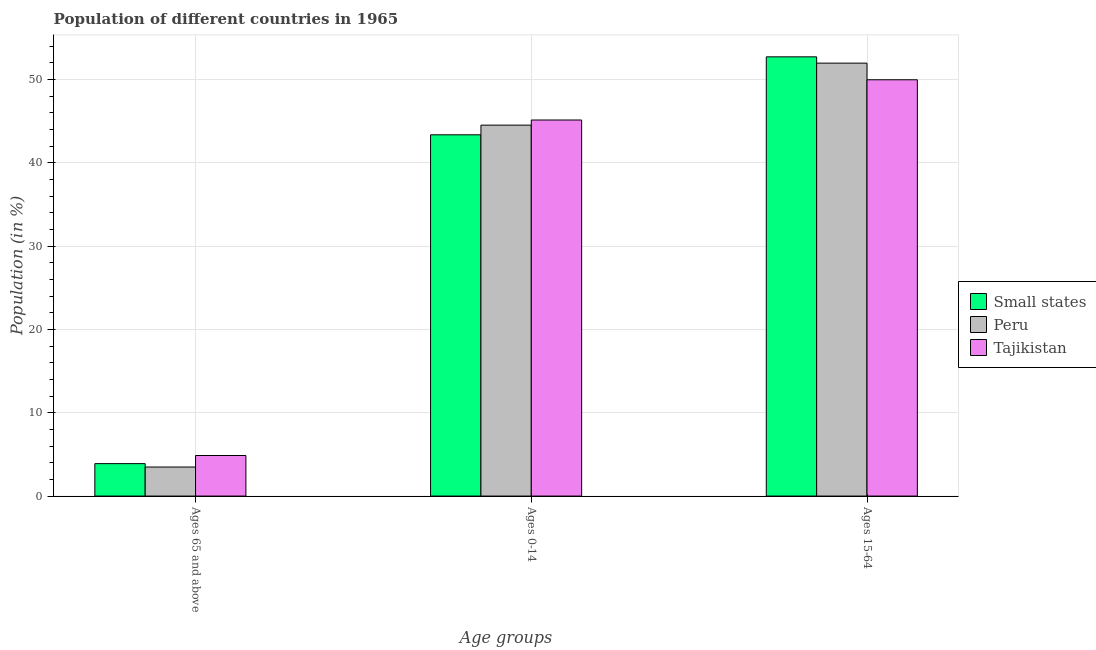How many different coloured bars are there?
Keep it short and to the point. 3. How many groups of bars are there?
Keep it short and to the point. 3. Are the number of bars on each tick of the X-axis equal?
Make the answer very short. Yes. How many bars are there on the 3rd tick from the right?
Offer a terse response. 3. What is the label of the 1st group of bars from the left?
Your answer should be compact. Ages 65 and above. What is the percentage of population within the age-group 0-14 in Peru?
Give a very brief answer. 44.53. Across all countries, what is the maximum percentage of population within the age-group of 65 and above?
Offer a very short reply. 4.87. Across all countries, what is the minimum percentage of population within the age-group 15-64?
Make the answer very short. 49.98. In which country was the percentage of population within the age-group 15-64 maximum?
Your answer should be very brief. Small states. In which country was the percentage of population within the age-group 0-14 minimum?
Your answer should be compact. Small states. What is the total percentage of population within the age-group of 65 and above in the graph?
Offer a very short reply. 12.25. What is the difference between the percentage of population within the age-group 0-14 in Small states and that in Tajikistan?
Keep it short and to the point. -1.78. What is the difference between the percentage of population within the age-group 15-64 in Small states and the percentage of population within the age-group 0-14 in Peru?
Your response must be concise. 8.2. What is the average percentage of population within the age-group of 65 and above per country?
Your answer should be compact. 4.08. What is the difference between the percentage of population within the age-group 15-64 and percentage of population within the age-group 0-14 in Peru?
Your answer should be compact. 7.44. In how many countries, is the percentage of population within the age-group 0-14 greater than 38 %?
Offer a very short reply. 3. What is the ratio of the percentage of population within the age-group of 65 and above in Peru to that in Tajikistan?
Offer a very short reply. 0.72. Is the percentage of population within the age-group of 65 and above in Tajikistan less than that in Small states?
Give a very brief answer. No. Is the difference between the percentage of population within the age-group of 65 and above in Peru and Tajikistan greater than the difference between the percentage of population within the age-group 0-14 in Peru and Tajikistan?
Your answer should be compact. No. What is the difference between the highest and the second highest percentage of population within the age-group 15-64?
Your answer should be compact. 0.76. What is the difference between the highest and the lowest percentage of population within the age-group of 65 and above?
Offer a very short reply. 1.38. What does the 2nd bar from the left in Ages 65 and above represents?
Offer a terse response. Peru. How many bars are there?
Your answer should be compact. 9. What is the difference between two consecutive major ticks on the Y-axis?
Offer a very short reply. 10. Does the graph contain any zero values?
Make the answer very short. No. Where does the legend appear in the graph?
Your answer should be very brief. Center right. How are the legend labels stacked?
Provide a succinct answer. Vertical. What is the title of the graph?
Ensure brevity in your answer.  Population of different countries in 1965. What is the label or title of the X-axis?
Make the answer very short. Age groups. What is the Population (in %) of Small states in Ages 65 and above?
Your answer should be compact. 3.89. What is the Population (in %) of Peru in Ages 65 and above?
Your answer should be compact. 3.49. What is the Population (in %) in Tajikistan in Ages 65 and above?
Ensure brevity in your answer.  4.87. What is the Population (in %) of Small states in Ages 0-14?
Your answer should be compact. 43.37. What is the Population (in %) in Peru in Ages 0-14?
Your response must be concise. 44.53. What is the Population (in %) of Tajikistan in Ages 0-14?
Your answer should be compact. 45.15. What is the Population (in %) of Small states in Ages 15-64?
Your answer should be very brief. 52.73. What is the Population (in %) in Peru in Ages 15-64?
Offer a very short reply. 51.98. What is the Population (in %) in Tajikistan in Ages 15-64?
Your answer should be very brief. 49.98. Across all Age groups, what is the maximum Population (in %) in Small states?
Your answer should be very brief. 52.73. Across all Age groups, what is the maximum Population (in %) in Peru?
Offer a terse response. 51.98. Across all Age groups, what is the maximum Population (in %) in Tajikistan?
Provide a short and direct response. 49.98. Across all Age groups, what is the minimum Population (in %) of Small states?
Your response must be concise. 3.89. Across all Age groups, what is the minimum Population (in %) of Peru?
Offer a terse response. 3.49. Across all Age groups, what is the minimum Population (in %) in Tajikistan?
Make the answer very short. 4.87. What is the total Population (in %) in Small states in the graph?
Offer a terse response. 100. What is the total Population (in %) in Tajikistan in the graph?
Ensure brevity in your answer.  100. What is the difference between the Population (in %) of Small states in Ages 65 and above and that in Ages 0-14?
Your answer should be very brief. -39.48. What is the difference between the Population (in %) of Peru in Ages 65 and above and that in Ages 0-14?
Give a very brief answer. -41.05. What is the difference between the Population (in %) in Tajikistan in Ages 65 and above and that in Ages 0-14?
Provide a short and direct response. -40.28. What is the difference between the Population (in %) in Small states in Ages 65 and above and that in Ages 15-64?
Your answer should be compact. -48.84. What is the difference between the Population (in %) of Peru in Ages 65 and above and that in Ages 15-64?
Provide a short and direct response. -48.49. What is the difference between the Population (in %) of Tajikistan in Ages 65 and above and that in Ages 15-64?
Your answer should be very brief. -45.11. What is the difference between the Population (in %) of Small states in Ages 0-14 and that in Ages 15-64?
Offer a very short reply. -9.36. What is the difference between the Population (in %) in Peru in Ages 0-14 and that in Ages 15-64?
Your response must be concise. -7.44. What is the difference between the Population (in %) in Tajikistan in Ages 0-14 and that in Ages 15-64?
Ensure brevity in your answer.  -4.83. What is the difference between the Population (in %) in Small states in Ages 65 and above and the Population (in %) in Peru in Ages 0-14?
Give a very brief answer. -40.64. What is the difference between the Population (in %) in Small states in Ages 65 and above and the Population (in %) in Tajikistan in Ages 0-14?
Keep it short and to the point. -41.26. What is the difference between the Population (in %) in Peru in Ages 65 and above and the Population (in %) in Tajikistan in Ages 0-14?
Keep it short and to the point. -41.66. What is the difference between the Population (in %) in Small states in Ages 65 and above and the Population (in %) in Peru in Ages 15-64?
Your answer should be very brief. -48.09. What is the difference between the Population (in %) in Small states in Ages 65 and above and the Population (in %) in Tajikistan in Ages 15-64?
Provide a succinct answer. -46.09. What is the difference between the Population (in %) in Peru in Ages 65 and above and the Population (in %) in Tajikistan in Ages 15-64?
Your response must be concise. -46.49. What is the difference between the Population (in %) of Small states in Ages 0-14 and the Population (in %) of Peru in Ages 15-64?
Keep it short and to the point. -8.61. What is the difference between the Population (in %) in Small states in Ages 0-14 and the Population (in %) in Tajikistan in Ages 15-64?
Your response must be concise. -6.61. What is the difference between the Population (in %) in Peru in Ages 0-14 and the Population (in %) in Tajikistan in Ages 15-64?
Offer a terse response. -5.45. What is the average Population (in %) of Small states per Age groups?
Offer a very short reply. 33.33. What is the average Population (in %) in Peru per Age groups?
Offer a terse response. 33.33. What is the average Population (in %) in Tajikistan per Age groups?
Offer a very short reply. 33.33. What is the difference between the Population (in %) of Small states and Population (in %) of Peru in Ages 65 and above?
Your answer should be very brief. 0.41. What is the difference between the Population (in %) in Small states and Population (in %) in Tajikistan in Ages 65 and above?
Your answer should be compact. -0.98. What is the difference between the Population (in %) of Peru and Population (in %) of Tajikistan in Ages 65 and above?
Offer a terse response. -1.38. What is the difference between the Population (in %) of Small states and Population (in %) of Peru in Ages 0-14?
Provide a short and direct response. -1.16. What is the difference between the Population (in %) in Small states and Population (in %) in Tajikistan in Ages 0-14?
Offer a very short reply. -1.78. What is the difference between the Population (in %) of Peru and Population (in %) of Tajikistan in Ages 0-14?
Keep it short and to the point. -0.62. What is the difference between the Population (in %) in Small states and Population (in %) in Peru in Ages 15-64?
Provide a short and direct response. 0.76. What is the difference between the Population (in %) in Small states and Population (in %) in Tajikistan in Ages 15-64?
Your response must be concise. 2.75. What is the difference between the Population (in %) of Peru and Population (in %) of Tajikistan in Ages 15-64?
Your response must be concise. 2. What is the ratio of the Population (in %) of Small states in Ages 65 and above to that in Ages 0-14?
Make the answer very short. 0.09. What is the ratio of the Population (in %) of Peru in Ages 65 and above to that in Ages 0-14?
Your answer should be very brief. 0.08. What is the ratio of the Population (in %) in Tajikistan in Ages 65 and above to that in Ages 0-14?
Keep it short and to the point. 0.11. What is the ratio of the Population (in %) in Small states in Ages 65 and above to that in Ages 15-64?
Your answer should be compact. 0.07. What is the ratio of the Population (in %) of Peru in Ages 65 and above to that in Ages 15-64?
Offer a very short reply. 0.07. What is the ratio of the Population (in %) of Tajikistan in Ages 65 and above to that in Ages 15-64?
Your response must be concise. 0.1. What is the ratio of the Population (in %) of Small states in Ages 0-14 to that in Ages 15-64?
Give a very brief answer. 0.82. What is the ratio of the Population (in %) in Peru in Ages 0-14 to that in Ages 15-64?
Make the answer very short. 0.86. What is the ratio of the Population (in %) in Tajikistan in Ages 0-14 to that in Ages 15-64?
Offer a very short reply. 0.9. What is the difference between the highest and the second highest Population (in %) in Small states?
Offer a very short reply. 9.36. What is the difference between the highest and the second highest Population (in %) of Peru?
Offer a terse response. 7.44. What is the difference between the highest and the second highest Population (in %) in Tajikistan?
Your answer should be very brief. 4.83. What is the difference between the highest and the lowest Population (in %) in Small states?
Offer a terse response. 48.84. What is the difference between the highest and the lowest Population (in %) of Peru?
Your answer should be compact. 48.49. What is the difference between the highest and the lowest Population (in %) in Tajikistan?
Offer a terse response. 45.11. 